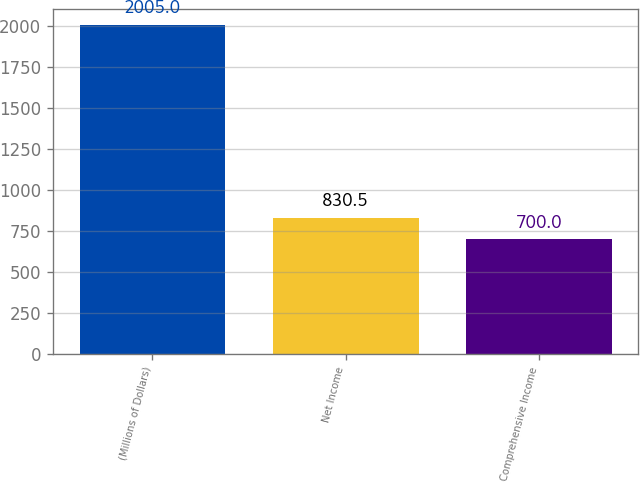<chart> <loc_0><loc_0><loc_500><loc_500><bar_chart><fcel>(Millions of Dollars)<fcel>Net Income<fcel>Comprehensive Income<nl><fcel>2005<fcel>830.5<fcel>700<nl></chart> 